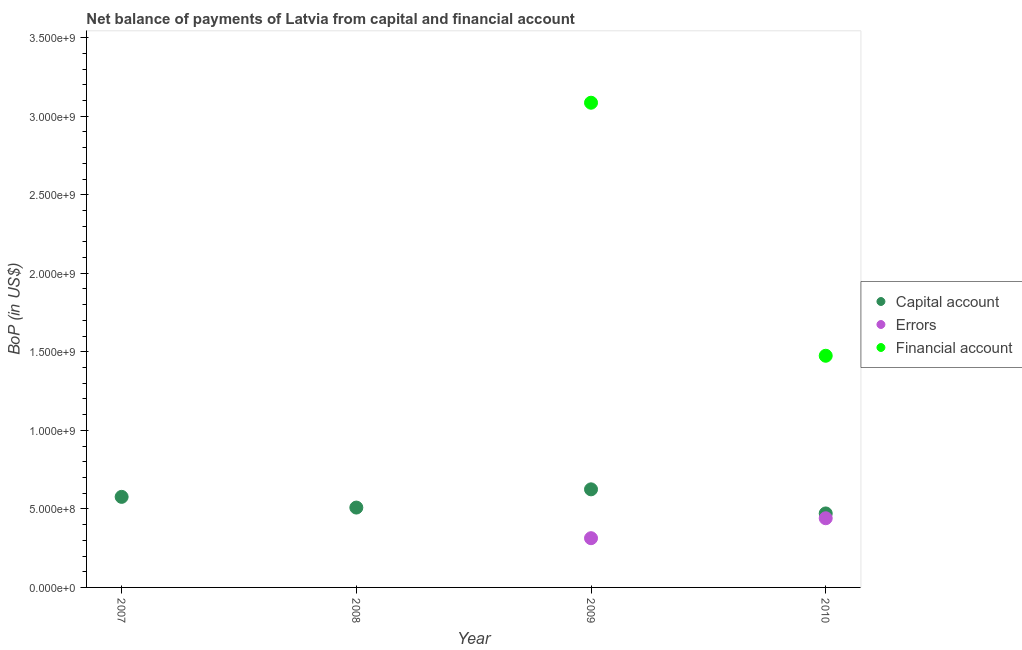Across all years, what is the maximum amount of errors?
Offer a very short reply. 4.40e+08. In which year was the amount of net capital account maximum?
Your answer should be very brief. 2009. What is the total amount of errors in the graph?
Give a very brief answer. 7.54e+08. What is the difference between the amount of errors in 2009 and that in 2010?
Your answer should be very brief. -1.27e+08. What is the difference between the amount of errors in 2007 and the amount of financial account in 2009?
Your answer should be very brief. -3.09e+09. What is the average amount of net capital account per year?
Offer a very short reply. 5.45e+08. In the year 2010, what is the difference between the amount of financial account and amount of net capital account?
Provide a succinct answer. 1.00e+09. In how many years, is the amount of financial account greater than 3400000000 US$?
Your answer should be very brief. 0. What is the ratio of the amount of net capital account in 2007 to that in 2009?
Your answer should be compact. 0.92. Is the amount of net capital account in 2008 less than that in 2009?
Provide a succinct answer. Yes. What is the difference between the highest and the second highest amount of net capital account?
Ensure brevity in your answer.  4.79e+07. What is the difference between the highest and the lowest amount of errors?
Your answer should be very brief. 4.40e+08. In how many years, is the amount of financial account greater than the average amount of financial account taken over all years?
Give a very brief answer. 2. Is the sum of the amount of net capital account in 2008 and 2009 greater than the maximum amount of financial account across all years?
Your answer should be very brief. No. Does the amount of financial account monotonically increase over the years?
Offer a very short reply. No. Is the amount of net capital account strictly greater than the amount of errors over the years?
Keep it short and to the point. Yes. Is the amount of financial account strictly less than the amount of errors over the years?
Your answer should be compact. No. Are the values on the major ticks of Y-axis written in scientific E-notation?
Offer a very short reply. Yes. How many legend labels are there?
Provide a short and direct response. 3. How are the legend labels stacked?
Make the answer very short. Vertical. What is the title of the graph?
Your answer should be very brief. Net balance of payments of Latvia from capital and financial account. What is the label or title of the Y-axis?
Give a very brief answer. BoP (in US$). What is the BoP (in US$) of Capital account in 2007?
Provide a succinct answer. 5.77e+08. What is the BoP (in US$) of Capital account in 2008?
Offer a very short reply. 5.08e+08. What is the BoP (in US$) of Errors in 2008?
Your answer should be compact. 0. What is the BoP (in US$) in Capital account in 2009?
Offer a very short reply. 6.24e+08. What is the BoP (in US$) of Errors in 2009?
Offer a terse response. 3.13e+08. What is the BoP (in US$) of Financial account in 2009?
Provide a short and direct response. 3.09e+09. What is the BoP (in US$) in Capital account in 2010?
Your answer should be very brief. 4.71e+08. What is the BoP (in US$) of Errors in 2010?
Your response must be concise. 4.40e+08. What is the BoP (in US$) of Financial account in 2010?
Your response must be concise. 1.47e+09. Across all years, what is the maximum BoP (in US$) in Capital account?
Your answer should be compact. 6.24e+08. Across all years, what is the maximum BoP (in US$) of Errors?
Keep it short and to the point. 4.40e+08. Across all years, what is the maximum BoP (in US$) in Financial account?
Provide a short and direct response. 3.09e+09. Across all years, what is the minimum BoP (in US$) of Capital account?
Make the answer very short. 4.71e+08. What is the total BoP (in US$) of Capital account in the graph?
Offer a very short reply. 2.18e+09. What is the total BoP (in US$) of Errors in the graph?
Give a very brief answer. 7.54e+08. What is the total BoP (in US$) of Financial account in the graph?
Keep it short and to the point. 4.56e+09. What is the difference between the BoP (in US$) of Capital account in 2007 and that in 2008?
Your answer should be very brief. 6.82e+07. What is the difference between the BoP (in US$) in Capital account in 2007 and that in 2009?
Your answer should be compact. -4.79e+07. What is the difference between the BoP (in US$) in Capital account in 2007 and that in 2010?
Ensure brevity in your answer.  1.06e+08. What is the difference between the BoP (in US$) of Capital account in 2008 and that in 2009?
Your answer should be very brief. -1.16e+08. What is the difference between the BoP (in US$) in Capital account in 2008 and that in 2010?
Your answer should be compact. 3.74e+07. What is the difference between the BoP (in US$) in Capital account in 2009 and that in 2010?
Your answer should be very brief. 1.53e+08. What is the difference between the BoP (in US$) of Errors in 2009 and that in 2010?
Provide a short and direct response. -1.27e+08. What is the difference between the BoP (in US$) in Financial account in 2009 and that in 2010?
Keep it short and to the point. 1.61e+09. What is the difference between the BoP (in US$) in Capital account in 2007 and the BoP (in US$) in Errors in 2009?
Make the answer very short. 2.63e+08. What is the difference between the BoP (in US$) of Capital account in 2007 and the BoP (in US$) of Financial account in 2009?
Your answer should be compact. -2.51e+09. What is the difference between the BoP (in US$) of Capital account in 2007 and the BoP (in US$) of Errors in 2010?
Make the answer very short. 1.36e+08. What is the difference between the BoP (in US$) of Capital account in 2007 and the BoP (in US$) of Financial account in 2010?
Your answer should be very brief. -8.98e+08. What is the difference between the BoP (in US$) in Capital account in 2008 and the BoP (in US$) in Errors in 2009?
Your answer should be compact. 1.95e+08. What is the difference between the BoP (in US$) in Capital account in 2008 and the BoP (in US$) in Financial account in 2009?
Provide a succinct answer. -2.58e+09. What is the difference between the BoP (in US$) of Capital account in 2008 and the BoP (in US$) of Errors in 2010?
Your answer should be very brief. 6.79e+07. What is the difference between the BoP (in US$) in Capital account in 2008 and the BoP (in US$) in Financial account in 2010?
Make the answer very short. -9.66e+08. What is the difference between the BoP (in US$) of Capital account in 2009 and the BoP (in US$) of Errors in 2010?
Offer a very short reply. 1.84e+08. What is the difference between the BoP (in US$) of Capital account in 2009 and the BoP (in US$) of Financial account in 2010?
Make the answer very short. -8.50e+08. What is the difference between the BoP (in US$) of Errors in 2009 and the BoP (in US$) of Financial account in 2010?
Your answer should be very brief. -1.16e+09. What is the average BoP (in US$) of Capital account per year?
Ensure brevity in your answer.  5.45e+08. What is the average BoP (in US$) of Errors per year?
Offer a terse response. 1.88e+08. What is the average BoP (in US$) of Financial account per year?
Ensure brevity in your answer.  1.14e+09. In the year 2009, what is the difference between the BoP (in US$) of Capital account and BoP (in US$) of Errors?
Provide a succinct answer. 3.11e+08. In the year 2009, what is the difference between the BoP (in US$) of Capital account and BoP (in US$) of Financial account?
Make the answer very short. -2.46e+09. In the year 2009, what is the difference between the BoP (in US$) in Errors and BoP (in US$) in Financial account?
Your answer should be compact. -2.77e+09. In the year 2010, what is the difference between the BoP (in US$) in Capital account and BoP (in US$) in Errors?
Your answer should be compact. 3.06e+07. In the year 2010, what is the difference between the BoP (in US$) in Capital account and BoP (in US$) in Financial account?
Provide a short and direct response. -1.00e+09. In the year 2010, what is the difference between the BoP (in US$) of Errors and BoP (in US$) of Financial account?
Provide a short and direct response. -1.03e+09. What is the ratio of the BoP (in US$) in Capital account in 2007 to that in 2008?
Your answer should be very brief. 1.13. What is the ratio of the BoP (in US$) of Capital account in 2007 to that in 2009?
Your answer should be very brief. 0.92. What is the ratio of the BoP (in US$) of Capital account in 2007 to that in 2010?
Give a very brief answer. 1.22. What is the ratio of the BoP (in US$) in Capital account in 2008 to that in 2009?
Offer a terse response. 0.81. What is the ratio of the BoP (in US$) in Capital account in 2008 to that in 2010?
Your answer should be compact. 1.08. What is the ratio of the BoP (in US$) of Capital account in 2009 to that in 2010?
Your answer should be very brief. 1.33. What is the ratio of the BoP (in US$) in Errors in 2009 to that in 2010?
Provide a succinct answer. 0.71. What is the ratio of the BoP (in US$) of Financial account in 2009 to that in 2010?
Your answer should be compact. 2.09. What is the difference between the highest and the second highest BoP (in US$) of Capital account?
Give a very brief answer. 4.79e+07. What is the difference between the highest and the lowest BoP (in US$) of Capital account?
Your answer should be very brief. 1.53e+08. What is the difference between the highest and the lowest BoP (in US$) of Errors?
Your response must be concise. 4.40e+08. What is the difference between the highest and the lowest BoP (in US$) in Financial account?
Make the answer very short. 3.09e+09. 